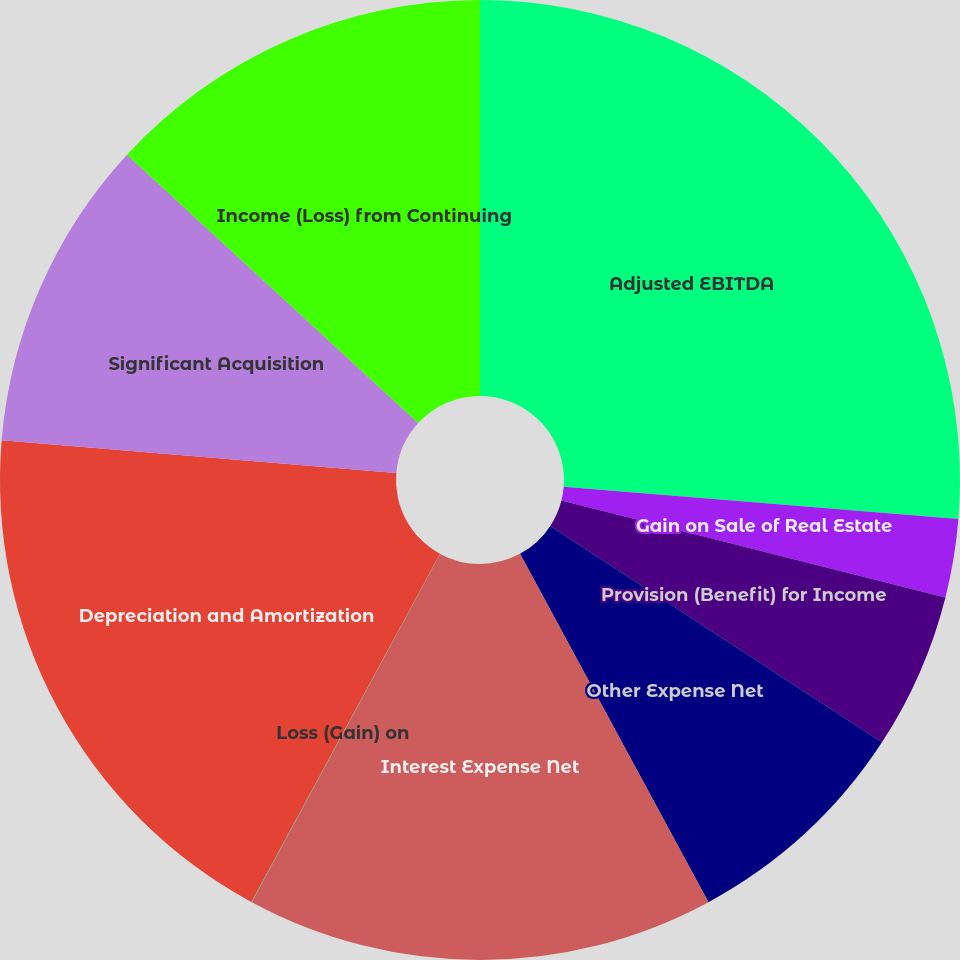<chart> <loc_0><loc_0><loc_500><loc_500><pie_chart><fcel>Adjusted EBITDA<fcel>Gain on Sale of Real Estate<fcel>Provision (Benefit) for Income<fcel>Other Expense Net<fcel>Interest Expense Net<fcel>Loss (Gain) on<fcel>Depreciation and Amortization<fcel>Significant Acquisition<fcel>Income (Loss) from Continuing<nl><fcel>26.29%<fcel>2.64%<fcel>5.27%<fcel>7.9%<fcel>15.78%<fcel>0.02%<fcel>18.41%<fcel>10.53%<fcel>13.15%<nl></chart> 